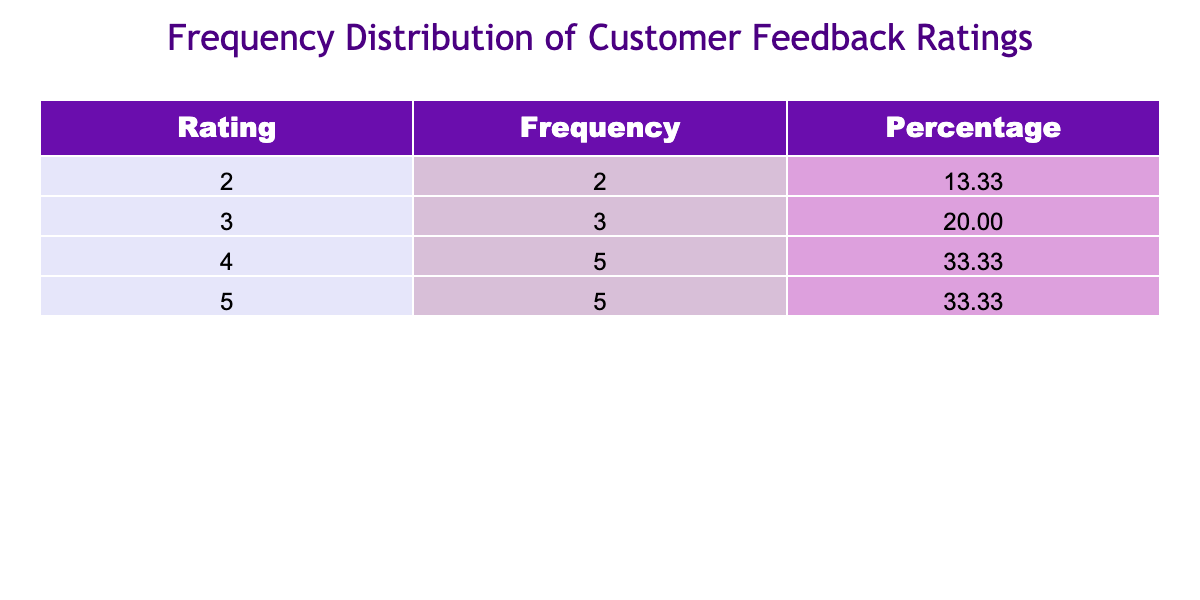What is the frequency of ratings of 5? The table shows that there are 5 instances with a rating of 5 when we refer to the Frequency column for that rating.
Answer: 5 What percentage of customer feedback ratings are 4? To find the percentage, locate the frequency for rating 4, which is 4, divide it by the total number of responses (20) and then multiply by 100. So, (4/20)*100 = 20%.
Answer: 20% Is there a rating of 2 among the feedback? By looking at the table, the rating of 2 appears; specifically, it has a frequency of 2. Thus, the answer is yes.
Answer: Yes Which rating has the highest frequency, and what is that frequency? The highest rating in the table is rating 5, with a frequency of 5, which is noted in the Frequency column.
Answer: Rating 5 has the highest frequency of 5 What is the average rating from the customer feedback? To calculate the average, we multiply each rating by its frequency, sum these products (5*5 + 4*4 + 3*3 + 2*2), and divide that sum by the total responses (20). The sum is 69 and thus the average rating is 69 / 20 = 3.45.
Answer: 3.45 How many ratings are above the average rating? The average rating is 3.45. Looking through the ratings (4 and 5), we find that there are 10 ratings (4s and 5s) above this average.
Answer: 10 Are there more ratings of 3 or ratings of 4? By checking the Frequency column, there are 3 ratings of 3 and 4 ratings of 4, which indicates there are more ratings of 4.
Answer: More ratings of 4 What is the total frequency for ratings lower than 4? The ratings lower than 4 are 2 and 3. Their frequencies are 2 (for 2) and 6 (for 3). When summed together, the total frequency is 8.
Answer: 8 Which rating category has the least frequency and what is that frequency? Referring to the table, ratings of 2 have the least frequency with a count of 2.
Answer: Rating 2 has the least frequency of 2 